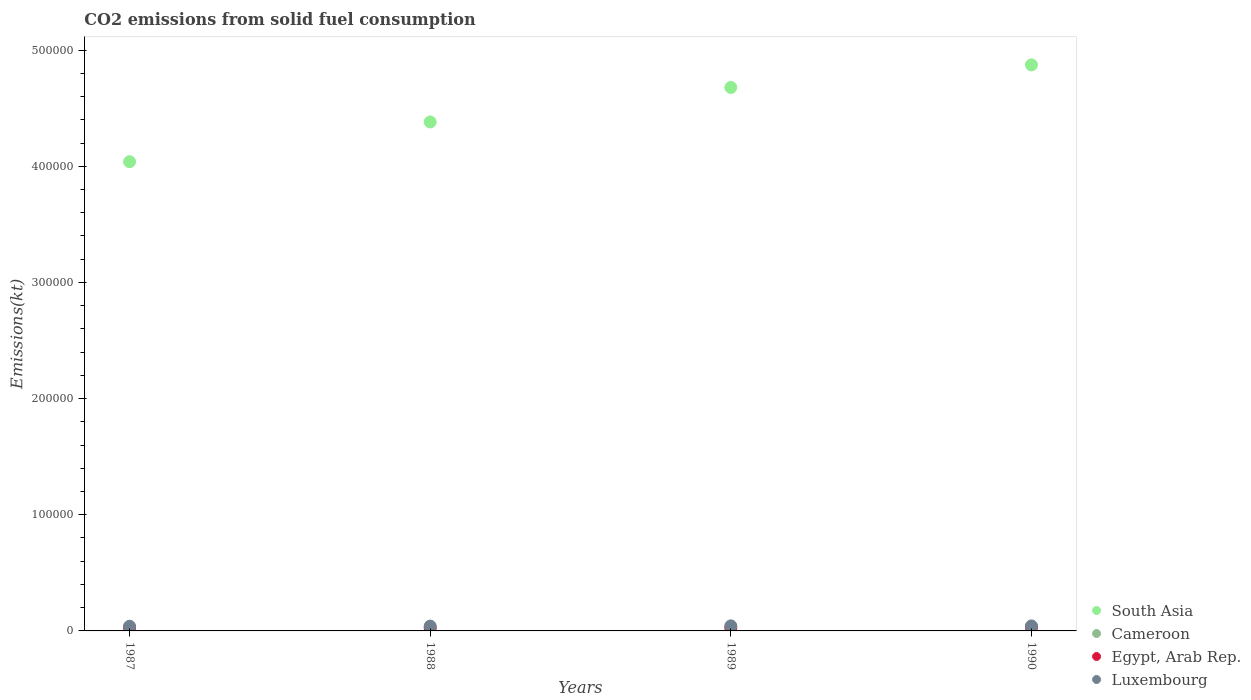How many different coloured dotlines are there?
Make the answer very short. 4. Is the number of dotlines equal to the number of legend labels?
Your response must be concise. Yes. What is the amount of CO2 emitted in South Asia in 1989?
Ensure brevity in your answer.  4.68e+05. Across all years, what is the maximum amount of CO2 emitted in South Asia?
Your answer should be compact. 4.87e+05. Across all years, what is the minimum amount of CO2 emitted in South Asia?
Keep it short and to the point. 4.04e+05. In which year was the amount of CO2 emitted in Egypt, Arab Rep. maximum?
Your answer should be very brief. 1990. What is the total amount of CO2 emitted in Egypt, Arab Rep. in the graph?
Provide a short and direct response. 1.17e+04. What is the difference between the amount of CO2 emitted in South Asia in 1988 and that in 1990?
Provide a short and direct response. -4.91e+04. What is the difference between the amount of CO2 emitted in Egypt, Arab Rep. in 1989 and the amount of CO2 emitted in Luxembourg in 1990?
Provide a succinct answer. -1459.47. What is the average amount of CO2 emitted in Luxembourg per year?
Provide a short and direct response. 4208.8. In the year 1990, what is the difference between the amount of CO2 emitted in Egypt, Arab Rep. and amount of CO2 emitted in South Asia?
Offer a very short reply. -4.84e+05. In how many years, is the amount of CO2 emitted in Cameroon greater than 160000 kt?
Keep it short and to the point. 0. What is the ratio of the amount of CO2 emitted in Egypt, Arab Rep. in 1987 to that in 1989?
Ensure brevity in your answer.  1.03. Is the amount of CO2 emitted in Cameroon in 1987 less than that in 1989?
Your response must be concise. No. What is the difference between the highest and the lowest amount of CO2 emitted in South Asia?
Your answer should be compact. 8.34e+04. In how many years, is the amount of CO2 emitted in Cameroon greater than the average amount of CO2 emitted in Cameroon taken over all years?
Your answer should be very brief. 0. Is it the case that in every year, the sum of the amount of CO2 emitted in South Asia and amount of CO2 emitted in Egypt, Arab Rep.  is greater than the sum of amount of CO2 emitted in Luxembourg and amount of CO2 emitted in Cameroon?
Provide a short and direct response. No. Does the amount of CO2 emitted in South Asia monotonically increase over the years?
Make the answer very short. Yes. Is the amount of CO2 emitted in Luxembourg strictly greater than the amount of CO2 emitted in Egypt, Arab Rep. over the years?
Provide a short and direct response. Yes. How many dotlines are there?
Ensure brevity in your answer.  4. How many years are there in the graph?
Offer a terse response. 4. Does the graph contain any zero values?
Make the answer very short. No. Does the graph contain grids?
Your response must be concise. No. What is the title of the graph?
Offer a terse response. CO2 emissions from solid fuel consumption. What is the label or title of the Y-axis?
Ensure brevity in your answer.  Emissions(kt). What is the Emissions(kt) of South Asia in 1987?
Offer a very short reply. 4.04e+05. What is the Emissions(kt) in Cameroon in 1987?
Give a very brief answer. 3.67. What is the Emissions(kt) of Egypt, Arab Rep. in 1987?
Keep it short and to the point. 2926.27. What is the Emissions(kt) in Luxembourg in 1987?
Your answer should be compact. 4026.37. What is the Emissions(kt) in South Asia in 1988?
Your answer should be compact. 4.38e+05. What is the Emissions(kt) in Cameroon in 1988?
Ensure brevity in your answer.  3.67. What is the Emissions(kt) in Egypt, Arab Rep. in 1988?
Keep it short and to the point. 2585.24. What is the Emissions(kt) in Luxembourg in 1988?
Offer a very short reply. 4158.38. What is the Emissions(kt) of South Asia in 1989?
Ensure brevity in your answer.  4.68e+05. What is the Emissions(kt) of Cameroon in 1989?
Ensure brevity in your answer.  3.67. What is the Emissions(kt) in Egypt, Arab Rep. in 1989?
Provide a short and direct response. 2834.59. What is the Emissions(kt) in Luxembourg in 1989?
Offer a terse response. 4356.4. What is the Emissions(kt) of South Asia in 1990?
Your response must be concise. 4.87e+05. What is the Emissions(kt) of Cameroon in 1990?
Provide a succinct answer. 3.67. What is the Emissions(kt) in Egypt, Arab Rep. in 1990?
Make the answer very short. 3362.64. What is the Emissions(kt) of Luxembourg in 1990?
Make the answer very short. 4294.06. Across all years, what is the maximum Emissions(kt) in South Asia?
Your answer should be very brief. 4.87e+05. Across all years, what is the maximum Emissions(kt) of Cameroon?
Provide a short and direct response. 3.67. Across all years, what is the maximum Emissions(kt) of Egypt, Arab Rep.?
Ensure brevity in your answer.  3362.64. Across all years, what is the maximum Emissions(kt) of Luxembourg?
Your answer should be compact. 4356.4. Across all years, what is the minimum Emissions(kt) in South Asia?
Give a very brief answer. 4.04e+05. Across all years, what is the minimum Emissions(kt) in Cameroon?
Your response must be concise. 3.67. Across all years, what is the minimum Emissions(kt) in Egypt, Arab Rep.?
Offer a terse response. 2585.24. Across all years, what is the minimum Emissions(kt) in Luxembourg?
Ensure brevity in your answer.  4026.37. What is the total Emissions(kt) of South Asia in the graph?
Make the answer very short. 1.80e+06. What is the total Emissions(kt) in Cameroon in the graph?
Give a very brief answer. 14.67. What is the total Emissions(kt) of Egypt, Arab Rep. in the graph?
Make the answer very short. 1.17e+04. What is the total Emissions(kt) in Luxembourg in the graph?
Keep it short and to the point. 1.68e+04. What is the difference between the Emissions(kt) in South Asia in 1987 and that in 1988?
Your answer should be very brief. -3.42e+04. What is the difference between the Emissions(kt) of Egypt, Arab Rep. in 1987 and that in 1988?
Give a very brief answer. 341.03. What is the difference between the Emissions(kt) in Luxembourg in 1987 and that in 1988?
Your response must be concise. -132.01. What is the difference between the Emissions(kt) of South Asia in 1987 and that in 1989?
Keep it short and to the point. -6.40e+04. What is the difference between the Emissions(kt) in Cameroon in 1987 and that in 1989?
Provide a short and direct response. 0. What is the difference between the Emissions(kt) in Egypt, Arab Rep. in 1987 and that in 1989?
Your answer should be compact. 91.67. What is the difference between the Emissions(kt) of Luxembourg in 1987 and that in 1989?
Your response must be concise. -330.03. What is the difference between the Emissions(kt) of South Asia in 1987 and that in 1990?
Provide a short and direct response. -8.34e+04. What is the difference between the Emissions(kt) of Cameroon in 1987 and that in 1990?
Your answer should be compact. 0. What is the difference between the Emissions(kt) in Egypt, Arab Rep. in 1987 and that in 1990?
Provide a short and direct response. -436.37. What is the difference between the Emissions(kt) in Luxembourg in 1987 and that in 1990?
Your answer should be compact. -267.69. What is the difference between the Emissions(kt) in South Asia in 1988 and that in 1989?
Offer a terse response. -2.97e+04. What is the difference between the Emissions(kt) of Egypt, Arab Rep. in 1988 and that in 1989?
Ensure brevity in your answer.  -249.36. What is the difference between the Emissions(kt) in Luxembourg in 1988 and that in 1989?
Offer a very short reply. -198.02. What is the difference between the Emissions(kt) of South Asia in 1988 and that in 1990?
Make the answer very short. -4.91e+04. What is the difference between the Emissions(kt) in Cameroon in 1988 and that in 1990?
Provide a succinct answer. 0. What is the difference between the Emissions(kt) in Egypt, Arab Rep. in 1988 and that in 1990?
Make the answer very short. -777.4. What is the difference between the Emissions(kt) in Luxembourg in 1988 and that in 1990?
Your answer should be compact. -135.68. What is the difference between the Emissions(kt) of South Asia in 1989 and that in 1990?
Provide a succinct answer. -1.94e+04. What is the difference between the Emissions(kt) of Cameroon in 1989 and that in 1990?
Offer a terse response. 0. What is the difference between the Emissions(kt) of Egypt, Arab Rep. in 1989 and that in 1990?
Provide a short and direct response. -528.05. What is the difference between the Emissions(kt) of Luxembourg in 1989 and that in 1990?
Offer a very short reply. 62.34. What is the difference between the Emissions(kt) of South Asia in 1987 and the Emissions(kt) of Cameroon in 1988?
Offer a terse response. 4.04e+05. What is the difference between the Emissions(kt) in South Asia in 1987 and the Emissions(kt) in Egypt, Arab Rep. in 1988?
Give a very brief answer. 4.01e+05. What is the difference between the Emissions(kt) in South Asia in 1987 and the Emissions(kt) in Luxembourg in 1988?
Give a very brief answer. 4.00e+05. What is the difference between the Emissions(kt) in Cameroon in 1987 and the Emissions(kt) in Egypt, Arab Rep. in 1988?
Your answer should be compact. -2581.57. What is the difference between the Emissions(kt) of Cameroon in 1987 and the Emissions(kt) of Luxembourg in 1988?
Provide a succinct answer. -4154.71. What is the difference between the Emissions(kt) of Egypt, Arab Rep. in 1987 and the Emissions(kt) of Luxembourg in 1988?
Give a very brief answer. -1232.11. What is the difference between the Emissions(kt) in South Asia in 1987 and the Emissions(kt) in Cameroon in 1989?
Offer a very short reply. 4.04e+05. What is the difference between the Emissions(kt) of South Asia in 1987 and the Emissions(kt) of Egypt, Arab Rep. in 1989?
Ensure brevity in your answer.  4.01e+05. What is the difference between the Emissions(kt) of South Asia in 1987 and the Emissions(kt) of Luxembourg in 1989?
Your response must be concise. 4.00e+05. What is the difference between the Emissions(kt) in Cameroon in 1987 and the Emissions(kt) in Egypt, Arab Rep. in 1989?
Offer a terse response. -2830.92. What is the difference between the Emissions(kt) of Cameroon in 1987 and the Emissions(kt) of Luxembourg in 1989?
Ensure brevity in your answer.  -4352.73. What is the difference between the Emissions(kt) in Egypt, Arab Rep. in 1987 and the Emissions(kt) in Luxembourg in 1989?
Your answer should be very brief. -1430.13. What is the difference between the Emissions(kt) of South Asia in 1987 and the Emissions(kt) of Cameroon in 1990?
Offer a terse response. 4.04e+05. What is the difference between the Emissions(kt) of South Asia in 1987 and the Emissions(kt) of Egypt, Arab Rep. in 1990?
Keep it short and to the point. 4.01e+05. What is the difference between the Emissions(kt) of South Asia in 1987 and the Emissions(kt) of Luxembourg in 1990?
Your answer should be compact. 4.00e+05. What is the difference between the Emissions(kt) of Cameroon in 1987 and the Emissions(kt) of Egypt, Arab Rep. in 1990?
Provide a succinct answer. -3358.97. What is the difference between the Emissions(kt) in Cameroon in 1987 and the Emissions(kt) in Luxembourg in 1990?
Offer a very short reply. -4290.39. What is the difference between the Emissions(kt) in Egypt, Arab Rep. in 1987 and the Emissions(kt) in Luxembourg in 1990?
Offer a terse response. -1367.79. What is the difference between the Emissions(kt) in South Asia in 1988 and the Emissions(kt) in Cameroon in 1989?
Offer a very short reply. 4.38e+05. What is the difference between the Emissions(kt) of South Asia in 1988 and the Emissions(kt) of Egypt, Arab Rep. in 1989?
Your answer should be very brief. 4.35e+05. What is the difference between the Emissions(kt) in South Asia in 1988 and the Emissions(kt) in Luxembourg in 1989?
Offer a very short reply. 4.34e+05. What is the difference between the Emissions(kt) in Cameroon in 1988 and the Emissions(kt) in Egypt, Arab Rep. in 1989?
Your answer should be very brief. -2830.92. What is the difference between the Emissions(kt) in Cameroon in 1988 and the Emissions(kt) in Luxembourg in 1989?
Your answer should be compact. -4352.73. What is the difference between the Emissions(kt) in Egypt, Arab Rep. in 1988 and the Emissions(kt) in Luxembourg in 1989?
Offer a terse response. -1771.16. What is the difference between the Emissions(kt) of South Asia in 1988 and the Emissions(kt) of Cameroon in 1990?
Keep it short and to the point. 4.38e+05. What is the difference between the Emissions(kt) of South Asia in 1988 and the Emissions(kt) of Egypt, Arab Rep. in 1990?
Provide a succinct answer. 4.35e+05. What is the difference between the Emissions(kt) of South Asia in 1988 and the Emissions(kt) of Luxembourg in 1990?
Offer a very short reply. 4.34e+05. What is the difference between the Emissions(kt) of Cameroon in 1988 and the Emissions(kt) of Egypt, Arab Rep. in 1990?
Your response must be concise. -3358.97. What is the difference between the Emissions(kt) in Cameroon in 1988 and the Emissions(kt) in Luxembourg in 1990?
Provide a succinct answer. -4290.39. What is the difference between the Emissions(kt) in Egypt, Arab Rep. in 1988 and the Emissions(kt) in Luxembourg in 1990?
Offer a very short reply. -1708.82. What is the difference between the Emissions(kt) of South Asia in 1989 and the Emissions(kt) of Cameroon in 1990?
Provide a short and direct response. 4.68e+05. What is the difference between the Emissions(kt) in South Asia in 1989 and the Emissions(kt) in Egypt, Arab Rep. in 1990?
Make the answer very short. 4.65e+05. What is the difference between the Emissions(kt) in South Asia in 1989 and the Emissions(kt) in Luxembourg in 1990?
Offer a very short reply. 4.64e+05. What is the difference between the Emissions(kt) of Cameroon in 1989 and the Emissions(kt) of Egypt, Arab Rep. in 1990?
Keep it short and to the point. -3358.97. What is the difference between the Emissions(kt) in Cameroon in 1989 and the Emissions(kt) in Luxembourg in 1990?
Your answer should be very brief. -4290.39. What is the difference between the Emissions(kt) in Egypt, Arab Rep. in 1989 and the Emissions(kt) in Luxembourg in 1990?
Give a very brief answer. -1459.47. What is the average Emissions(kt) of South Asia per year?
Give a very brief answer. 4.49e+05. What is the average Emissions(kt) in Cameroon per year?
Your answer should be compact. 3.67. What is the average Emissions(kt) of Egypt, Arab Rep. per year?
Offer a terse response. 2927.18. What is the average Emissions(kt) in Luxembourg per year?
Your answer should be very brief. 4208.8. In the year 1987, what is the difference between the Emissions(kt) of South Asia and Emissions(kt) of Cameroon?
Provide a short and direct response. 4.04e+05. In the year 1987, what is the difference between the Emissions(kt) of South Asia and Emissions(kt) of Egypt, Arab Rep.?
Your response must be concise. 4.01e+05. In the year 1987, what is the difference between the Emissions(kt) in South Asia and Emissions(kt) in Luxembourg?
Offer a very short reply. 4.00e+05. In the year 1987, what is the difference between the Emissions(kt) in Cameroon and Emissions(kt) in Egypt, Arab Rep.?
Your answer should be compact. -2922.6. In the year 1987, what is the difference between the Emissions(kt) of Cameroon and Emissions(kt) of Luxembourg?
Give a very brief answer. -4022.7. In the year 1987, what is the difference between the Emissions(kt) of Egypt, Arab Rep. and Emissions(kt) of Luxembourg?
Give a very brief answer. -1100.1. In the year 1988, what is the difference between the Emissions(kt) of South Asia and Emissions(kt) of Cameroon?
Provide a succinct answer. 4.38e+05. In the year 1988, what is the difference between the Emissions(kt) of South Asia and Emissions(kt) of Egypt, Arab Rep.?
Keep it short and to the point. 4.36e+05. In the year 1988, what is the difference between the Emissions(kt) of South Asia and Emissions(kt) of Luxembourg?
Your response must be concise. 4.34e+05. In the year 1988, what is the difference between the Emissions(kt) in Cameroon and Emissions(kt) in Egypt, Arab Rep.?
Make the answer very short. -2581.57. In the year 1988, what is the difference between the Emissions(kt) in Cameroon and Emissions(kt) in Luxembourg?
Your answer should be very brief. -4154.71. In the year 1988, what is the difference between the Emissions(kt) of Egypt, Arab Rep. and Emissions(kt) of Luxembourg?
Offer a very short reply. -1573.14. In the year 1989, what is the difference between the Emissions(kt) in South Asia and Emissions(kt) in Cameroon?
Give a very brief answer. 4.68e+05. In the year 1989, what is the difference between the Emissions(kt) of South Asia and Emissions(kt) of Egypt, Arab Rep.?
Provide a short and direct response. 4.65e+05. In the year 1989, what is the difference between the Emissions(kt) in South Asia and Emissions(kt) in Luxembourg?
Give a very brief answer. 4.64e+05. In the year 1989, what is the difference between the Emissions(kt) in Cameroon and Emissions(kt) in Egypt, Arab Rep.?
Give a very brief answer. -2830.92. In the year 1989, what is the difference between the Emissions(kt) of Cameroon and Emissions(kt) of Luxembourg?
Ensure brevity in your answer.  -4352.73. In the year 1989, what is the difference between the Emissions(kt) in Egypt, Arab Rep. and Emissions(kt) in Luxembourg?
Offer a terse response. -1521.81. In the year 1990, what is the difference between the Emissions(kt) in South Asia and Emissions(kt) in Cameroon?
Provide a short and direct response. 4.87e+05. In the year 1990, what is the difference between the Emissions(kt) in South Asia and Emissions(kt) in Egypt, Arab Rep.?
Keep it short and to the point. 4.84e+05. In the year 1990, what is the difference between the Emissions(kt) in South Asia and Emissions(kt) in Luxembourg?
Offer a terse response. 4.83e+05. In the year 1990, what is the difference between the Emissions(kt) of Cameroon and Emissions(kt) of Egypt, Arab Rep.?
Ensure brevity in your answer.  -3358.97. In the year 1990, what is the difference between the Emissions(kt) of Cameroon and Emissions(kt) of Luxembourg?
Ensure brevity in your answer.  -4290.39. In the year 1990, what is the difference between the Emissions(kt) in Egypt, Arab Rep. and Emissions(kt) in Luxembourg?
Your response must be concise. -931.42. What is the ratio of the Emissions(kt) in South Asia in 1987 to that in 1988?
Offer a very short reply. 0.92. What is the ratio of the Emissions(kt) of Egypt, Arab Rep. in 1987 to that in 1988?
Provide a succinct answer. 1.13. What is the ratio of the Emissions(kt) in Luxembourg in 1987 to that in 1988?
Offer a very short reply. 0.97. What is the ratio of the Emissions(kt) in South Asia in 1987 to that in 1989?
Your answer should be very brief. 0.86. What is the ratio of the Emissions(kt) of Cameroon in 1987 to that in 1989?
Your answer should be compact. 1. What is the ratio of the Emissions(kt) of Egypt, Arab Rep. in 1987 to that in 1989?
Provide a succinct answer. 1.03. What is the ratio of the Emissions(kt) in Luxembourg in 1987 to that in 1989?
Your answer should be compact. 0.92. What is the ratio of the Emissions(kt) of South Asia in 1987 to that in 1990?
Offer a very short reply. 0.83. What is the ratio of the Emissions(kt) of Cameroon in 1987 to that in 1990?
Ensure brevity in your answer.  1. What is the ratio of the Emissions(kt) in Egypt, Arab Rep. in 1987 to that in 1990?
Make the answer very short. 0.87. What is the ratio of the Emissions(kt) in Luxembourg in 1987 to that in 1990?
Offer a very short reply. 0.94. What is the ratio of the Emissions(kt) of South Asia in 1988 to that in 1989?
Your response must be concise. 0.94. What is the ratio of the Emissions(kt) of Egypt, Arab Rep. in 1988 to that in 1989?
Your response must be concise. 0.91. What is the ratio of the Emissions(kt) of Luxembourg in 1988 to that in 1989?
Offer a terse response. 0.95. What is the ratio of the Emissions(kt) of South Asia in 1988 to that in 1990?
Provide a short and direct response. 0.9. What is the ratio of the Emissions(kt) in Cameroon in 1988 to that in 1990?
Provide a short and direct response. 1. What is the ratio of the Emissions(kt) of Egypt, Arab Rep. in 1988 to that in 1990?
Make the answer very short. 0.77. What is the ratio of the Emissions(kt) of Luxembourg in 1988 to that in 1990?
Your response must be concise. 0.97. What is the ratio of the Emissions(kt) in South Asia in 1989 to that in 1990?
Keep it short and to the point. 0.96. What is the ratio of the Emissions(kt) of Egypt, Arab Rep. in 1989 to that in 1990?
Your answer should be very brief. 0.84. What is the ratio of the Emissions(kt) in Luxembourg in 1989 to that in 1990?
Offer a very short reply. 1.01. What is the difference between the highest and the second highest Emissions(kt) of South Asia?
Offer a terse response. 1.94e+04. What is the difference between the highest and the second highest Emissions(kt) of Cameroon?
Your answer should be compact. 0. What is the difference between the highest and the second highest Emissions(kt) in Egypt, Arab Rep.?
Offer a terse response. 436.37. What is the difference between the highest and the second highest Emissions(kt) of Luxembourg?
Keep it short and to the point. 62.34. What is the difference between the highest and the lowest Emissions(kt) of South Asia?
Ensure brevity in your answer.  8.34e+04. What is the difference between the highest and the lowest Emissions(kt) in Egypt, Arab Rep.?
Keep it short and to the point. 777.4. What is the difference between the highest and the lowest Emissions(kt) in Luxembourg?
Offer a terse response. 330.03. 